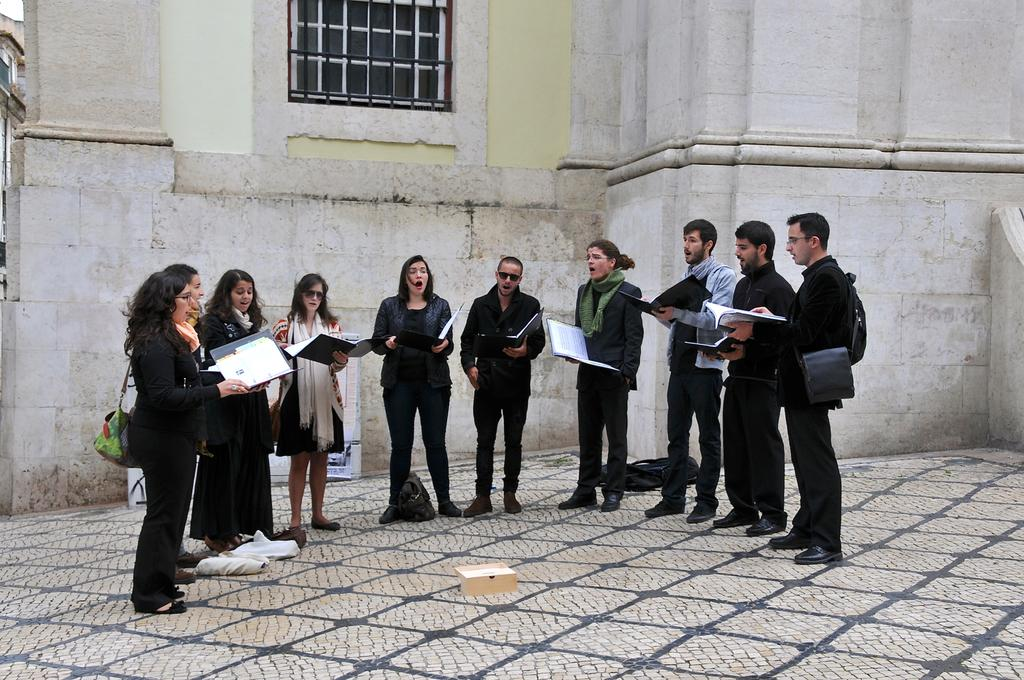What are the people in the image doing? The people in the image are standing and singing. What objects are some of the people holding? Some of the people are holding books and bags. Are there any bags on the ground in the image? Yes, there are bags on the ground in the image. What can be seen in the background of the image? There is a building with windows in the background. What type of net can be seen in the image? There is no net present in the image. Can you describe the elbow of the person in the front row? There is no specific person mentioned in the image, and no elbow is visible or described in the provided facts. 